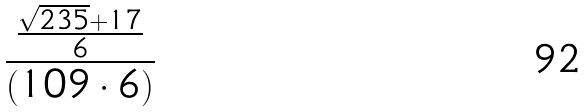Convert formula to latex. <formula><loc_0><loc_0><loc_500><loc_500>\frac { \frac { \sqrt { 2 3 5 } + 1 7 } { 6 } } { ( 1 0 9 \cdot 6 ) }</formula> 